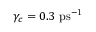<formula> <loc_0><loc_0><loc_500><loc_500>\gamma _ { c } = 0 . 3 p s ^ { - 1 }</formula> 